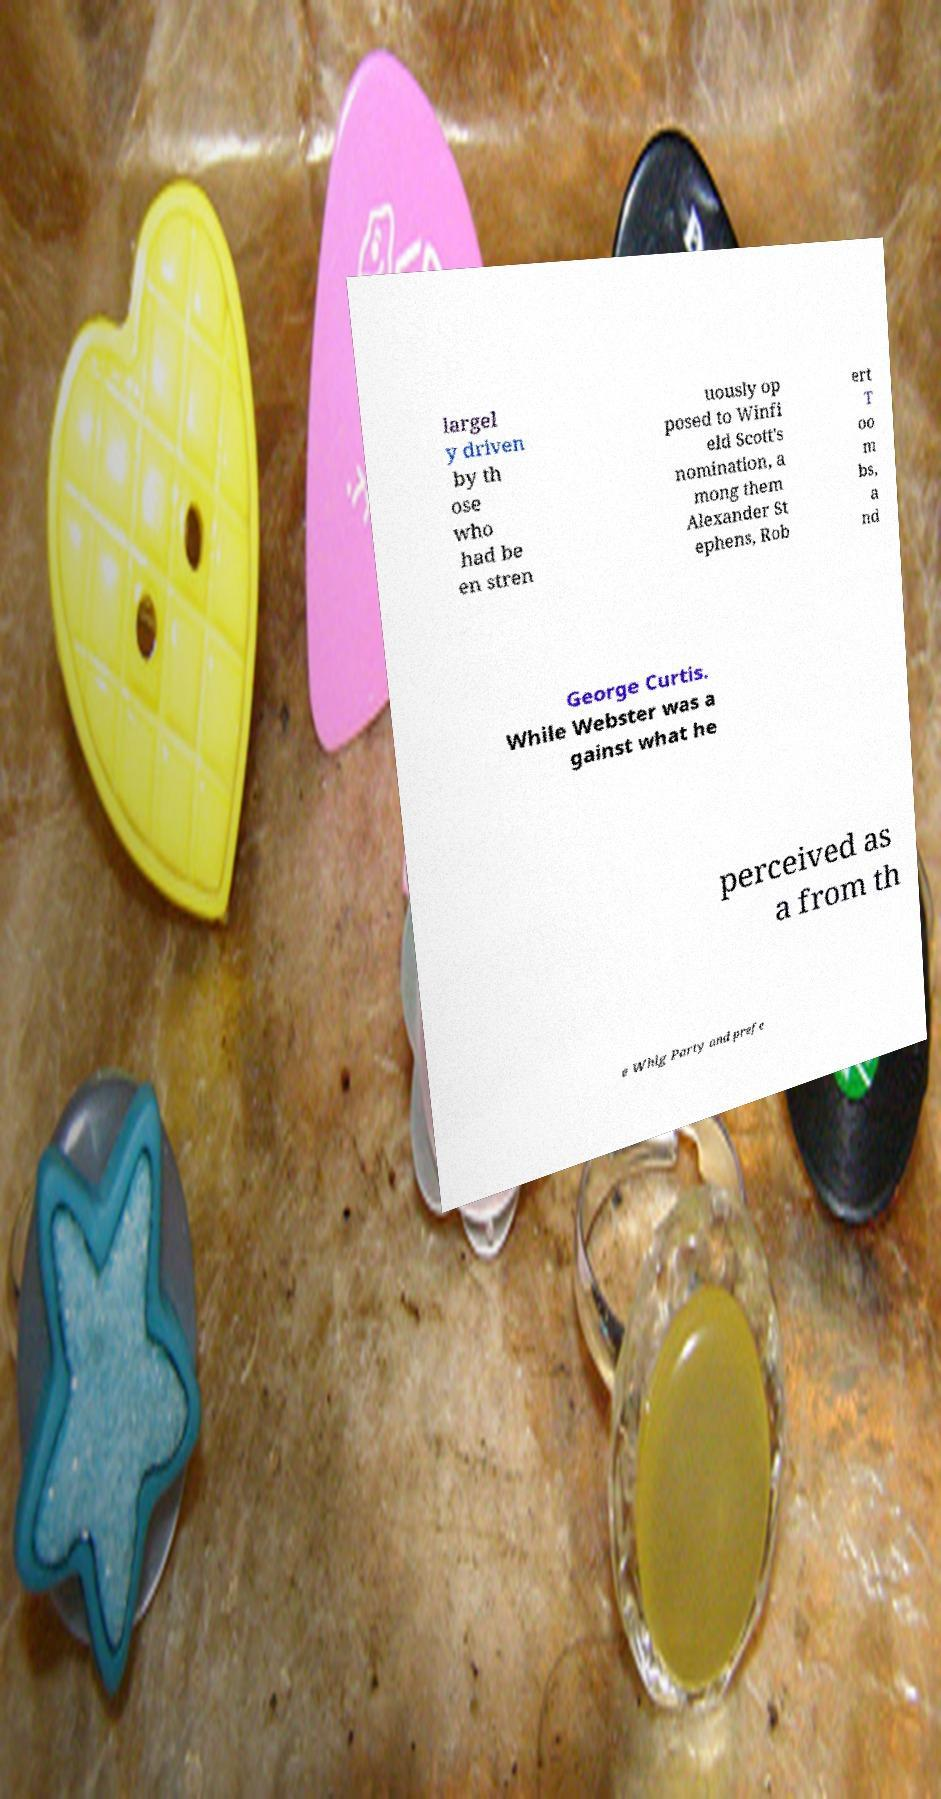Please read and relay the text visible in this image. What does it say? largel y driven by th ose who had be en stren uously op posed to Winfi eld Scott's nomination, a mong them Alexander St ephens, Rob ert T oo m bs, a nd George Curtis. While Webster was a gainst what he perceived as a from th e Whig Party and prefe 